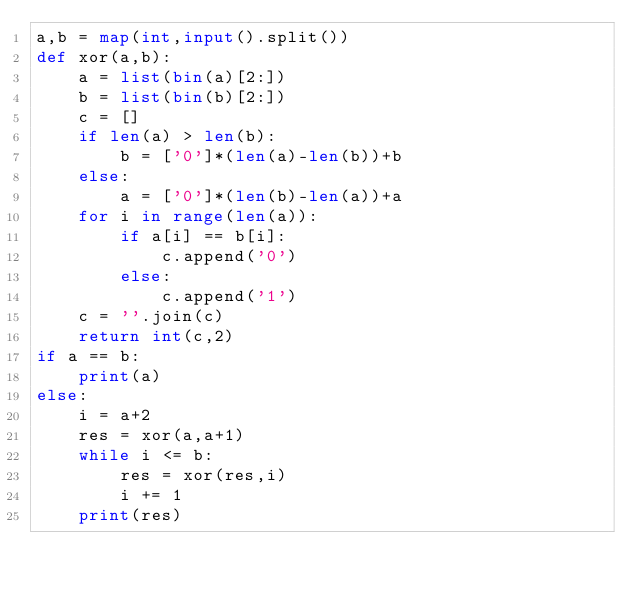Convert code to text. <code><loc_0><loc_0><loc_500><loc_500><_Python_>a,b = map(int,input().split())
def xor(a,b):
    a = list(bin(a)[2:])
    b = list(bin(b)[2:])
    c = []
    if len(a) > len(b):
        b = ['0']*(len(a)-len(b))+b
    else:
        a = ['0']*(len(b)-len(a))+a
    for i in range(len(a)):
        if a[i] == b[i]:
            c.append('0')
        else:
            c.append('1')
    c = ''.join(c)
    return int(c,2)
if a == b:
    print(a)
else:
    i = a+2
    res = xor(a,a+1)
    while i <= b:
        res = xor(res,i)
        i += 1
    print(res)</code> 